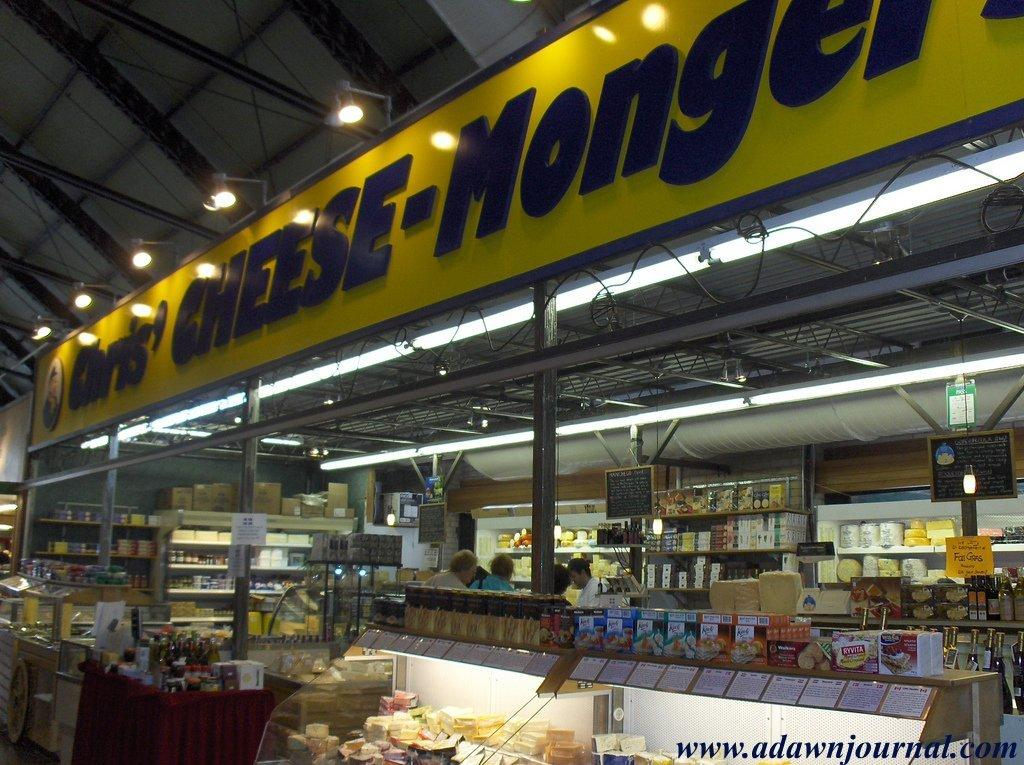<image>
Offer a succinct explanation of the picture presented. A few people shopping at Chris' Cheese-Mongers cheese shop 